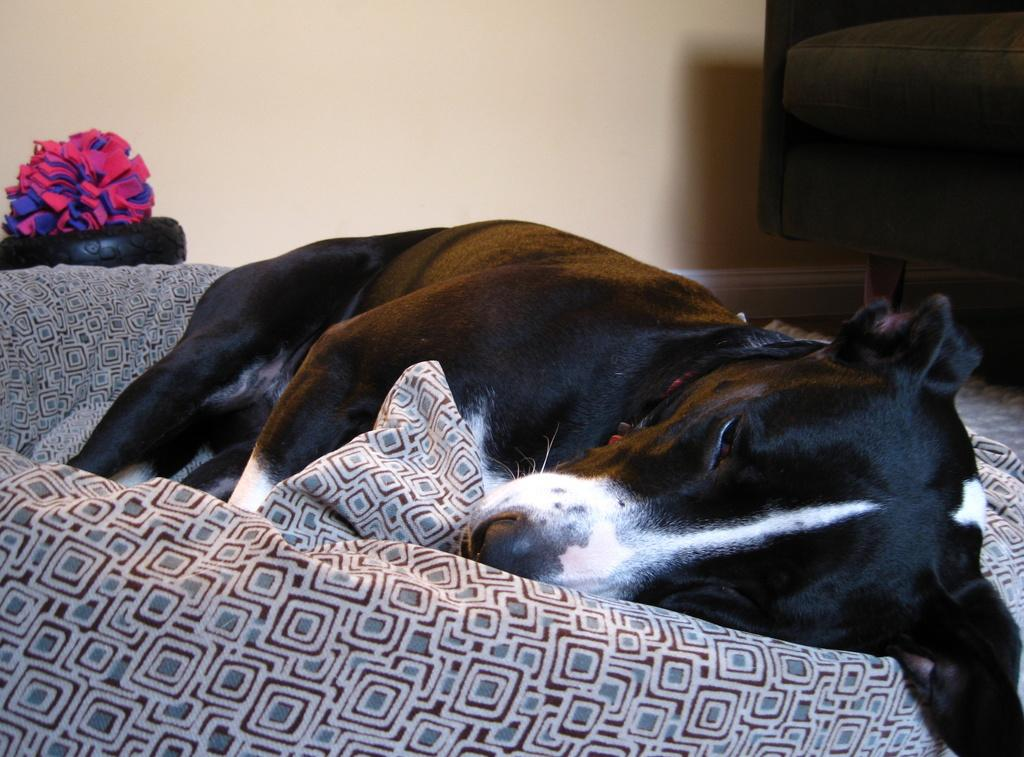What type of structure can be seen in the image? There is a wall in the image. What type of furniture is present in the image? There are sofas in the image. What type of material is visible in the image? There is cloth visible in the image. What type of animal is in the image? There is a black dog in the image. What is the dog doing in the image? The dog is sleeping on a sofa. How many eyes does the calculator have in the image? There is no calculator present in the image, so it is not possible to determine the number of eyes it might have. 